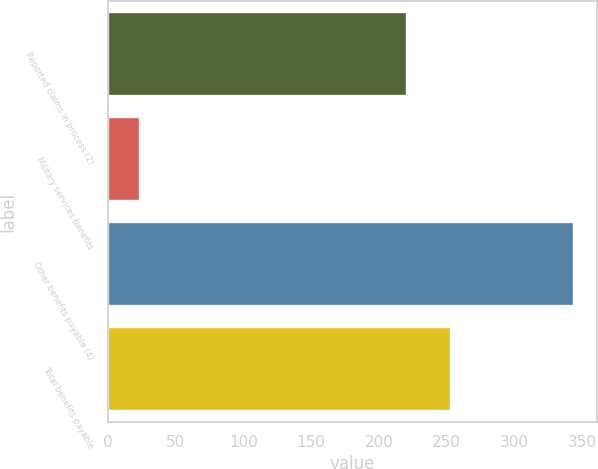<chart> <loc_0><loc_0><loc_500><loc_500><bar_chart><fcel>Reported claims in process (2)<fcel>Military services benefits<fcel>Other benefits payable (4)<fcel>Total benefits payable<nl><fcel>221<fcel>24<fcel>344<fcel>253<nl></chart> 